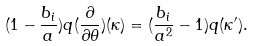Convert formula to latex. <formula><loc_0><loc_0><loc_500><loc_500>( 1 - \frac { b _ { i } } { a } ) q ( \frac { \partial } { \partial \theta } ) ( \kappa ) = ( \frac { b _ { i } } { a ^ { 2 } } - 1 ) q ( \kappa ^ { \prime } ) .</formula> 